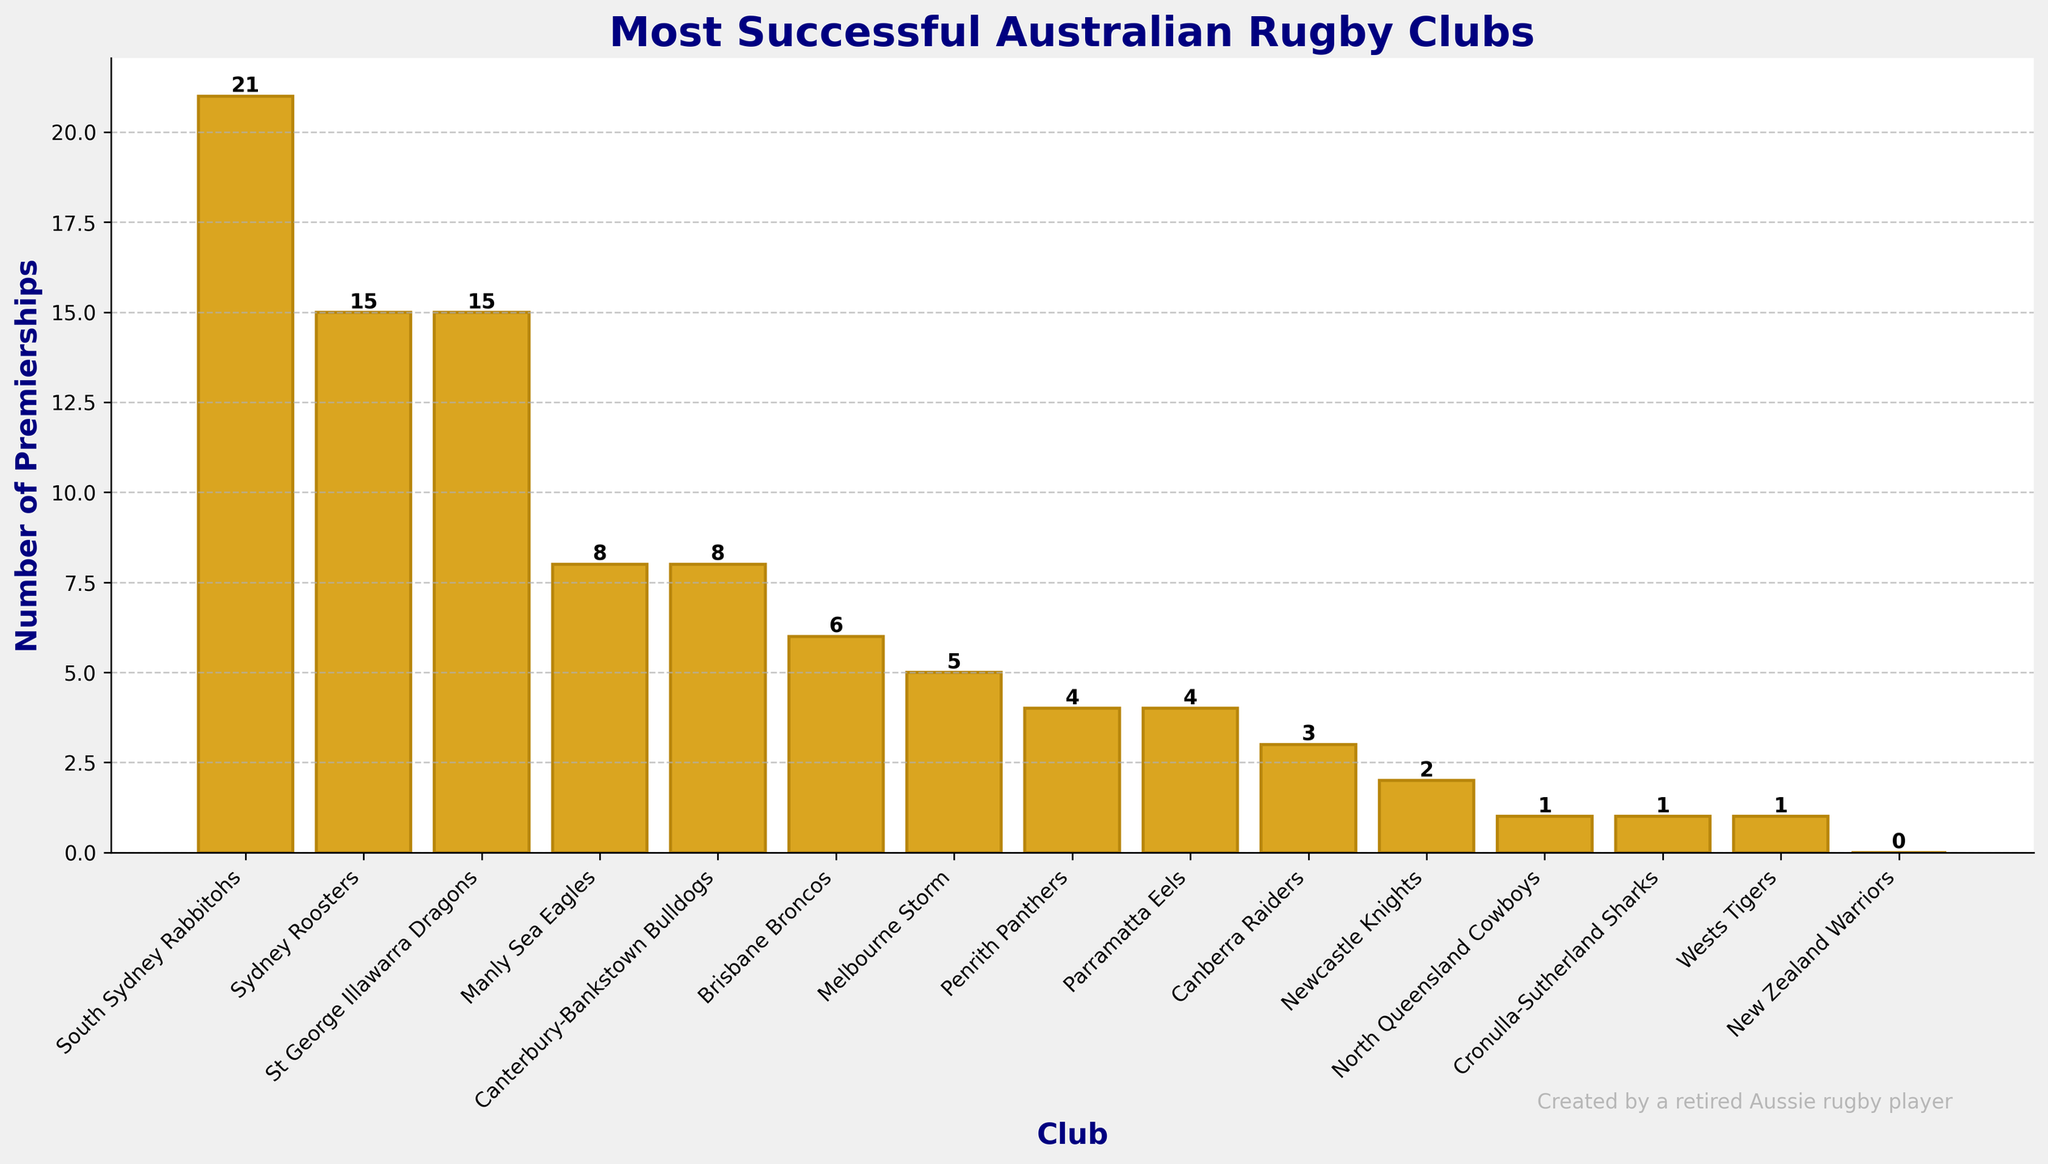Which club has won the most premierships? The bar chart shows the number of premierships won by each club, and the tallest bar represents the club with the most premierships. South Sydney Rabbitohs have the tallest bar with 21 premierships.
Answer: South Sydney Rabbitohs What is the total number of premierships won by Melbourne Storm and Manly Sea Eagles combined? Melbourne Storm has won 5 premierships and Manly Sea Eagles have won 8 premierships. Adding them gives 5 + 8 = 13.
Answer: 13 Which clubs have won fewer premierships than Penrith Panthers? Penrith Panthers have won 4 premierships. The clubs with fewer premierships are Canberra Raiders (3), Newcastle Knights (2), North Queensland Cowboys (1), Cronulla-Sutherland Sharks (1), Wests Tigers (1), and New Zealand Warriors (0).
Answer: 6 clubs How many clubs have won exactly 1 premiership? The bar chart has bars indicating the number of premierships. By counting bars with exactly 1 premiership, we get North Queensland Cowboys, Cronulla-Sutherland Sharks, and Wests Tigers, so 3 clubs.
Answer: 3 Which club is more successful, Sydney Roosters or St George Illawarra Dragons? The chart shows that both Sydney Roosters and St George Illawarra Dragons have won 15 premierships each, making them equally successful.
Answer: Equally successful What's the difference in the number of premierships between the Brisbane Broncos and the Newcastle Knights? Brisbane Broncos have won 6 premierships while Newcastle Knights have won 2 premierships. The difference is 6 - 2 = 4.
Answer: 4 What is the total number of premierships won by all clubs combined? Adding the premierships of all clubs: 21 + 15 + 15 + 8 + 8 + 6 + 5 + 4 + 4 + 3 + 2 + 1 + 1 + 1 + 0 = 94.
Answer: 94 What percentage of the total number of premierships is held by South Sydney Rabbitohs? South Sydney Rabbitohs have won 21 premierships. The total number of premierships is 94. The percentage is (21 / 94) * 100 ≈ 22.34%.
Answer: 22.34% Compare the premierships between Canberra Raiders and Parramatta Eels. Who has more? Canberra Raiders have 3 premierships, while Parramatta Eels have 4 premierships. Thus, Parramatta Eels have more.
Answer: Parramatta Eels Identify the clubs with bars colored differently. All bars are colored goldenrod with dark goldenrod edges. There are no differently colored bars.
Answer: No differently colored 